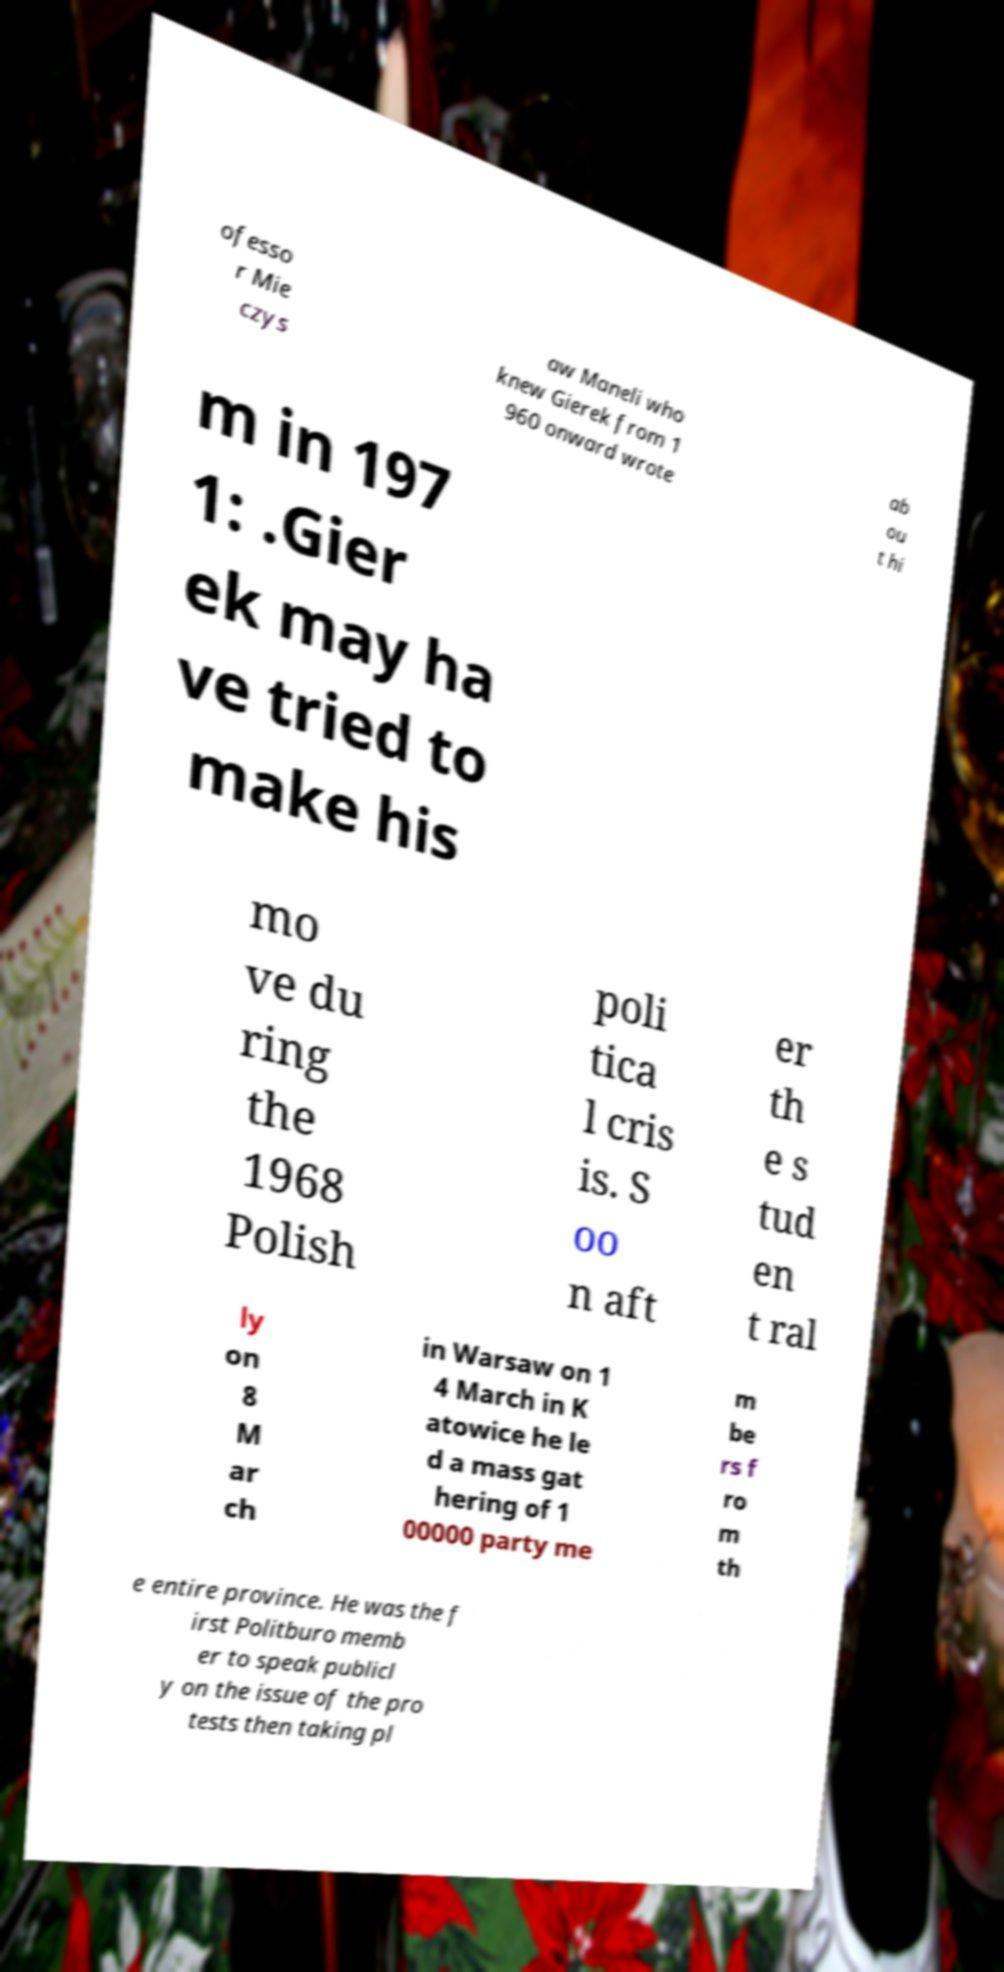Can you accurately transcribe the text from the provided image for me? ofesso r Mie czys aw Maneli who knew Gierek from 1 960 onward wrote ab ou t hi m in 197 1: .Gier ek may ha ve tried to make his mo ve du ring the 1968 Polish poli tica l cris is. S oo n aft er th e s tud en t ral ly on 8 M ar ch in Warsaw on 1 4 March in K atowice he le d a mass gat hering of 1 00000 party me m be rs f ro m th e entire province. He was the f irst Politburo memb er to speak publicl y on the issue of the pro tests then taking pl 